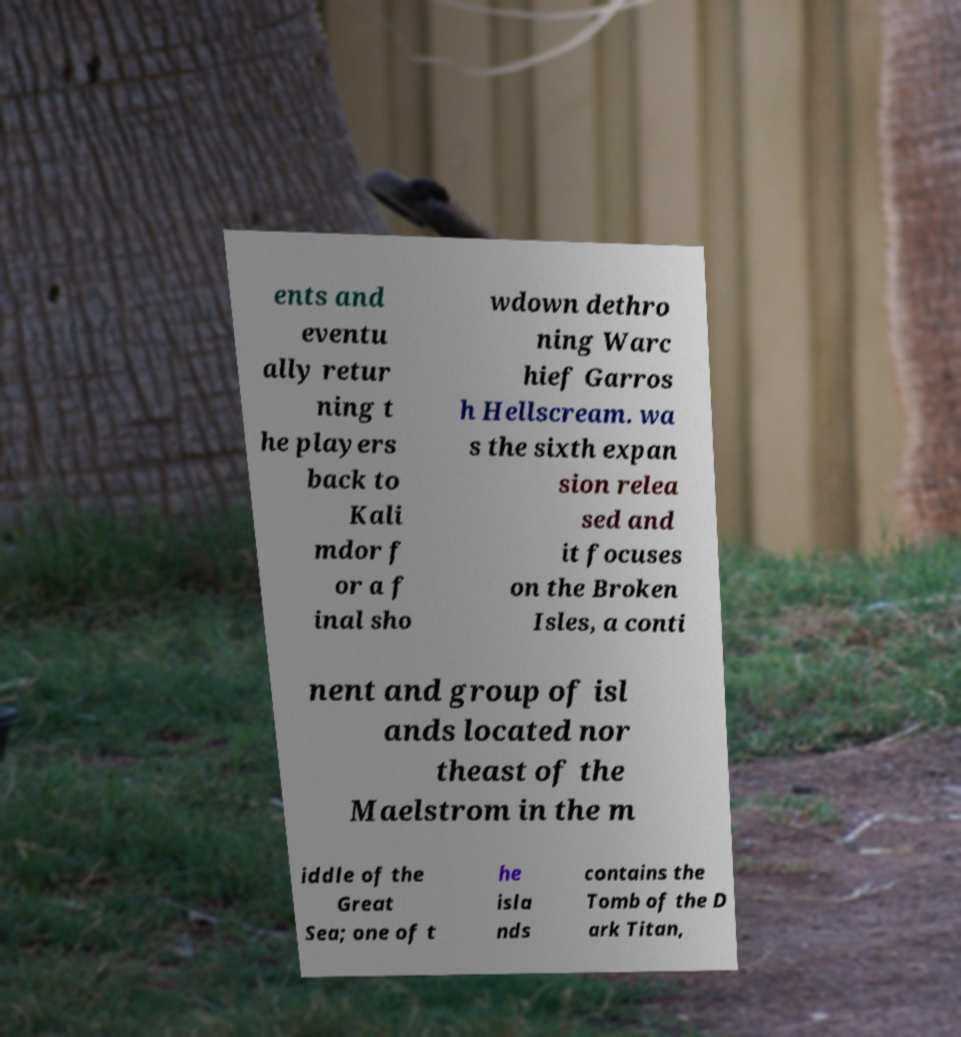Please identify and transcribe the text found in this image. ents and eventu ally retur ning t he players back to Kali mdor f or a f inal sho wdown dethro ning Warc hief Garros h Hellscream. wa s the sixth expan sion relea sed and it focuses on the Broken Isles, a conti nent and group of isl ands located nor theast of the Maelstrom in the m iddle of the Great Sea; one of t he isla nds contains the Tomb of the D ark Titan, 